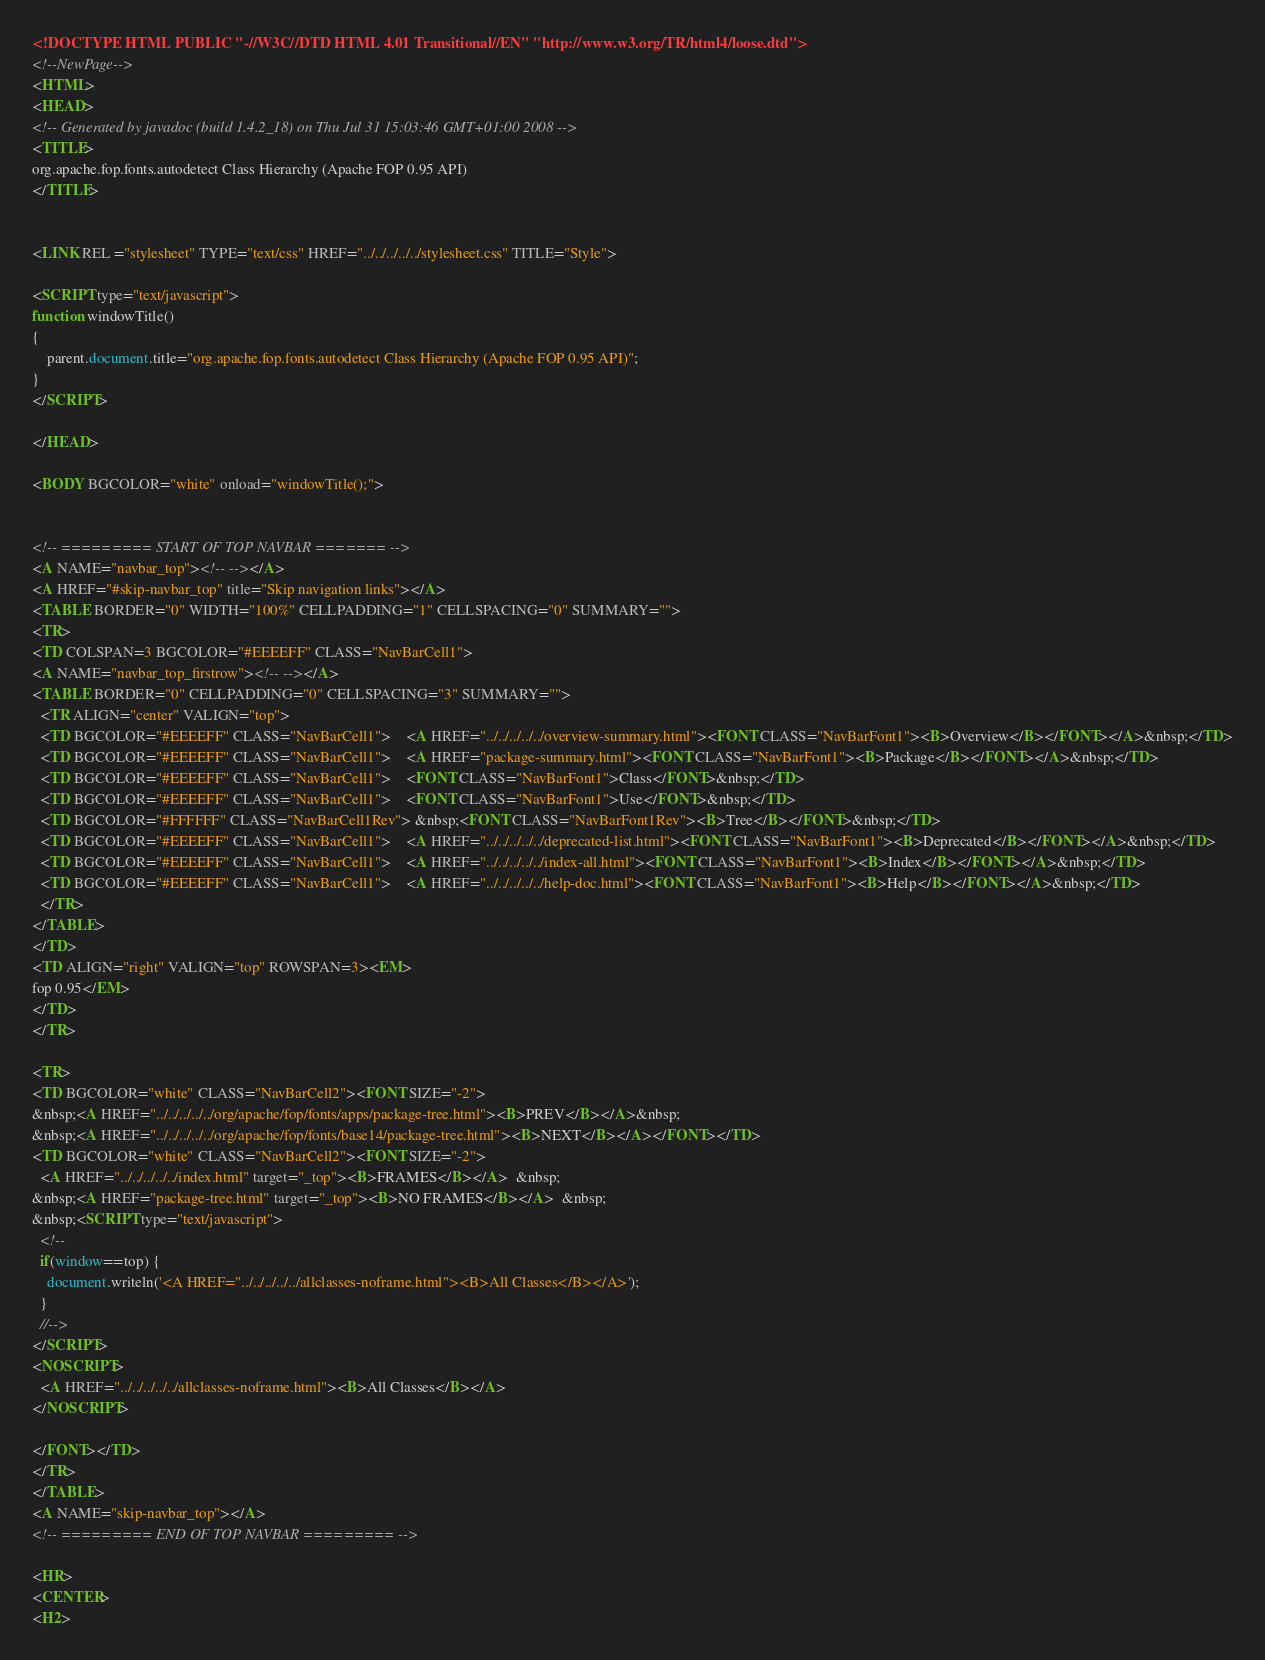Convert code to text. <code><loc_0><loc_0><loc_500><loc_500><_HTML_><!DOCTYPE HTML PUBLIC "-//W3C//DTD HTML 4.01 Transitional//EN" "http://www.w3.org/TR/html4/loose.dtd">
<!--NewPage-->
<HTML>
<HEAD>
<!-- Generated by javadoc (build 1.4.2_18) on Thu Jul 31 15:03:46 GMT+01:00 2008 -->
<TITLE>
org.apache.fop.fonts.autodetect Class Hierarchy (Apache FOP 0.95 API)
</TITLE>


<LINK REL ="stylesheet" TYPE="text/css" HREF="../../../../../stylesheet.css" TITLE="Style">

<SCRIPT type="text/javascript">
function windowTitle()
{
    parent.document.title="org.apache.fop.fonts.autodetect Class Hierarchy (Apache FOP 0.95 API)";
}
</SCRIPT>

</HEAD>

<BODY BGCOLOR="white" onload="windowTitle();">


<!-- ========= START OF TOP NAVBAR ======= -->
<A NAME="navbar_top"><!-- --></A>
<A HREF="#skip-navbar_top" title="Skip navigation links"></A>
<TABLE BORDER="0" WIDTH="100%" CELLPADDING="1" CELLSPACING="0" SUMMARY="">
<TR>
<TD COLSPAN=3 BGCOLOR="#EEEEFF" CLASS="NavBarCell1">
<A NAME="navbar_top_firstrow"><!-- --></A>
<TABLE BORDER="0" CELLPADDING="0" CELLSPACING="3" SUMMARY="">
  <TR ALIGN="center" VALIGN="top">
  <TD BGCOLOR="#EEEEFF" CLASS="NavBarCell1">    <A HREF="../../../../../overview-summary.html"><FONT CLASS="NavBarFont1"><B>Overview</B></FONT></A>&nbsp;</TD>
  <TD BGCOLOR="#EEEEFF" CLASS="NavBarCell1">    <A HREF="package-summary.html"><FONT CLASS="NavBarFont1"><B>Package</B></FONT></A>&nbsp;</TD>
  <TD BGCOLOR="#EEEEFF" CLASS="NavBarCell1">    <FONT CLASS="NavBarFont1">Class</FONT>&nbsp;</TD>
  <TD BGCOLOR="#EEEEFF" CLASS="NavBarCell1">    <FONT CLASS="NavBarFont1">Use</FONT>&nbsp;</TD>
  <TD BGCOLOR="#FFFFFF" CLASS="NavBarCell1Rev"> &nbsp;<FONT CLASS="NavBarFont1Rev"><B>Tree</B></FONT>&nbsp;</TD>
  <TD BGCOLOR="#EEEEFF" CLASS="NavBarCell1">    <A HREF="../../../../../deprecated-list.html"><FONT CLASS="NavBarFont1"><B>Deprecated</B></FONT></A>&nbsp;</TD>
  <TD BGCOLOR="#EEEEFF" CLASS="NavBarCell1">    <A HREF="../../../../../index-all.html"><FONT CLASS="NavBarFont1"><B>Index</B></FONT></A>&nbsp;</TD>
  <TD BGCOLOR="#EEEEFF" CLASS="NavBarCell1">    <A HREF="../../../../../help-doc.html"><FONT CLASS="NavBarFont1"><B>Help</B></FONT></A>&nbsp;</TD>
  </TR>
</TABLE>
</TD>
<TD ALIGN="right" VALIGN="top" ROWSPAN=3><EM>
fop 0.95</EM>
</TD>
</TR>

<TR>
<TD BGCOLOR="white" CLASS="NavBarCell2"><FONT SIZE="-2">
&nbsp;<A HREF="../../../../../org/apache/fop/fonts/apps/package-tree.html"><B>PREV</B></A>&nbsp;
&nbsp;<A HREF="../../../../../org/apache/fop/fonts/base14/package-tree.html"><B>NEXT</B></A></FONT></TD>
<TD BGCOLOR="white" CLASS="NavBarCell2"><FONT SIZE="-2">
  <A HREF="../../../../../index.html" target="_top"><B>FRAMES</B></A>  &nbsp;
&nbsp;<A HREF="package-tree.html" target="_top"><B>NO FRAMES</B></A>  &nbsp;
&nbsp;<SCRIPT type="text/javascript">
  <!--
  if(window==top) {
    document.writeln('<A HREF="../../../../../allclasses-noframe.html"><B>All Classes</B></A>');
  }
  //-->
</SCRIPT>
<NOSCRIPT>
  <A HREF="../../../../../allclasses-noframe.html"><B>All Classes</B></A>
</NOSCRIPT>

</FONT></TD>
</TR>
</TABLE>
<A NAME="skip-navbar_top"></A>
<!-- ========= END OF TOP NAVBAR ========= -->

<HR>
<CENTER>
<H2></code> 